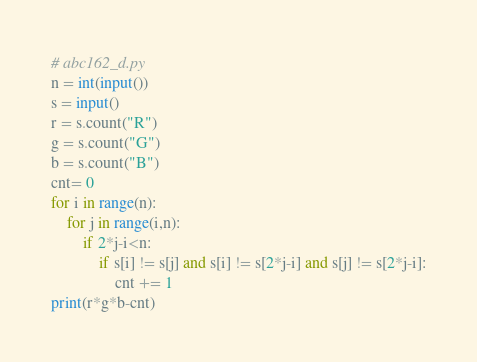Convert code to text. <code><loc_0><loc_0><loc_500><loc_500><_Python_># abc162_d.py
n = int(input())
s = input()
r = s.count("R")
g = s.count("G")
b = s.count("B")
cnt= 0
for i in range(n):
    for j in range(i,n):
        if 2*j-i<n:
            if s[i] != s[j] and s[i] != s[2*j-i] and s[j] != s[2*j-i]:
                cnt += 1
print(r*g*b-cnt)</code> 